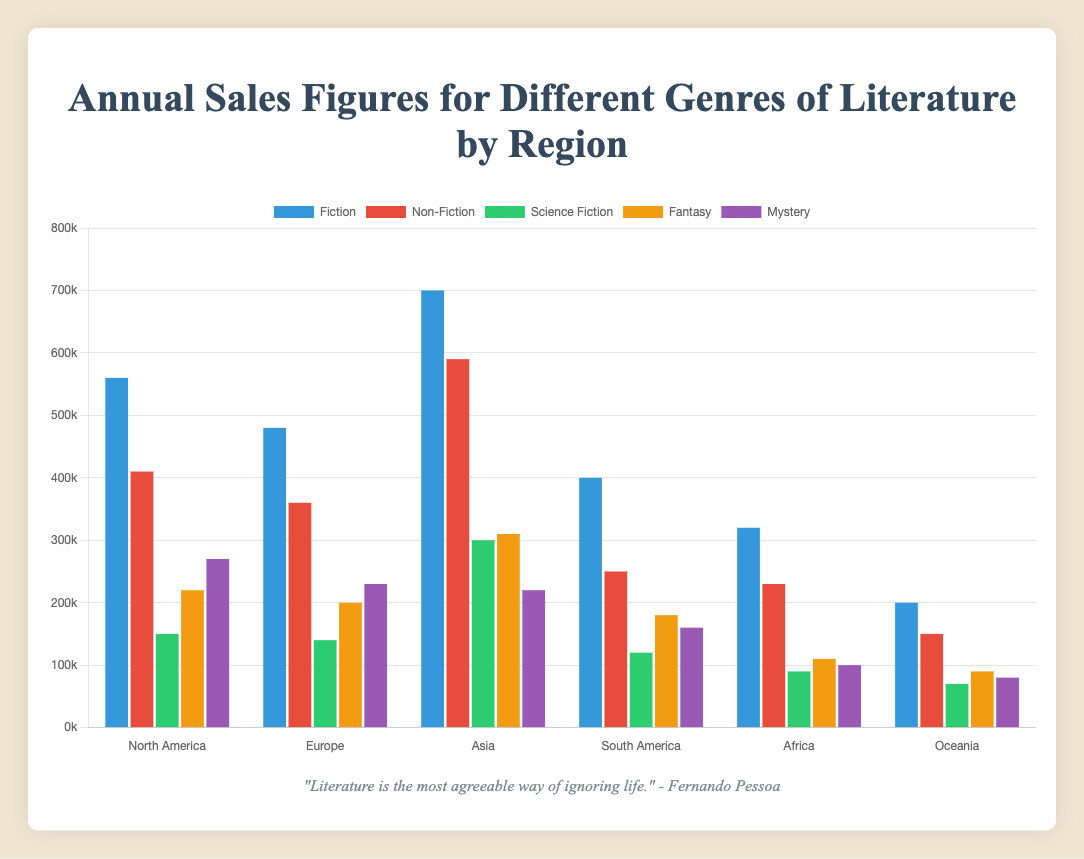Which region has the highest sales figures for Non-Fiction? To determine this, look at the heights of the Non-Fiction bar for each region and identify the tallest one. In the figure, Asia has the tallest Non-Fiction bar.
Answer: Asia Which genre has the lowest sales in Oceania? Examine the heights and colors of the bars representing different genres in Oceania. The Science Fiction bar is the shortest, indicating the lowest sales.
Answer: Science Fiction How much higher are Science Fiction sales in Asia compared to Europe? Subtract the Science Fiction sales figure for Europe from the figure for Asia. The calculation is 300,000 - 140,000 = 160,000.
Answer: 160,000 In North America, are the Fiction sales greater than the combined sales of Science Fiction and Mystery? Add the sales figures for Science Fiction and Mystery in North America: 150,000 + 270,000 = 420,000. Then, compare this with the Fiction sales: 560,000. Since 560,000 > 420,000, the Fiction sales are indeed greater.
Answer: Yes Rank the regions from highest to lowest in Fantasy sales. By comparing the heights of the Fantasy bars for each region, we get: Asia (310,000), North America (220,000), Europe (200,000), South America (180,000), Africa (110,000), and Oceania (90,000).
Answer: Asia, North America, Europe, South America, Africa, Oceania Is the combined sales of Fiction and Non-Fiction in Europe less than in Asia? First, calculate the combined sales in Europe: 480,000 (Fiction) + 360,000 (Non-Fiction) = 840,000. Do the same for Asia: 700,000 (Fiction) + 590,000 (Non-Fiction) = 1,290,000. Then, compare 840,000 and 1,290,000. Since 840,000 < 1,290,000, the answer is yes.
Answer: Yes Which genre in Africa has higher sales: Mystery or Fantasy? Visually compare the heights of the Mystery and Fantasy bars in Africa. The Fantasy bar is taller, indicating higher sales.
Answer: Fantasy What is the average sales figure for Science Fiction across all regions? Add up the Science Fiction sales figures for all regions: 150,000 (NA) + 140,000 (Europe) + 300,000 (Asia) + 120,000 (SA) + 90,000 (Africa) + 70,000 (Oceania) = 870,000. Then, divide by the number of regions (6): 870,000 / 6 ≈ 145,000.
Answer: 145,000 Compare the Mystery sales in North America to those in Africa and Oceania combined. Is North America higher? Add the Mystery sales figures for Africa and Oceania: 100,000 + 80,000 = 180,000. Compare this with the North American figure: 270,000. Since 270,000 > 180,000, the answer is yes.
Answer: Yes 